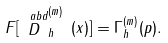<formula> <loc_0><loc_0><loc_500><loc_500>F [ \stackrel { \ a b d } { D } _ { h } ^ { ( m ) } \, ( x ) ] = \Gamma _ { h } ^ { ( m ) } ( p ) .</formula> 